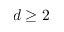<formula> <loc_0><loc_0><loc_500><loc_500>d \geq 2</formula> 